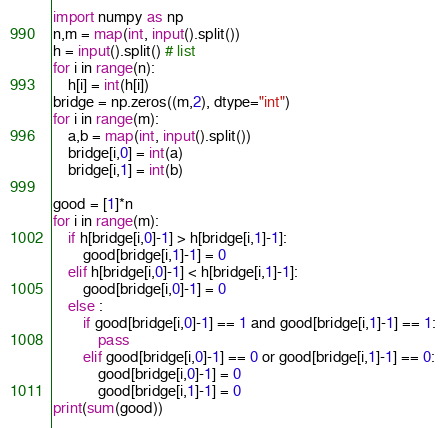Convert code to text. <code><loc_0><loc_0><loc_500><loc_500><_Python_>import numpy as np
n,m = map(int, input().split())
h = input().split() # list
for i in range(n):
    h[i] = int(h[i])
bridge = np.zeros((m,2), dtype="int")
for i in range(m):
    a,b = map(int, input().split())
    bridge[i,0] = int(a)
    bridge[i,1] = int(b)

good = [1]*n
for i in range(m):
    if h[bridge[i,0]-1] > h[bridge[i,1]-1]:
        good[bridge[i,1]-1] = 0
    elif h[bridge[i,0]-1] < h[bridge[i,1]-1]:
        good[bridge[i,0]-1] = 0
    else :
        if good[bridge[i,0]-1] == 1 and good[bridge[i,1]-1] == 1:
            pass
        elif good[bridge[i,0]-1] == 0 or good[bridge[i,1]-1] == 0:
            good[bridge[i,0]-1] = 0
            good[bridge[i,1]-1] = 0
print(sum(good))</code> 